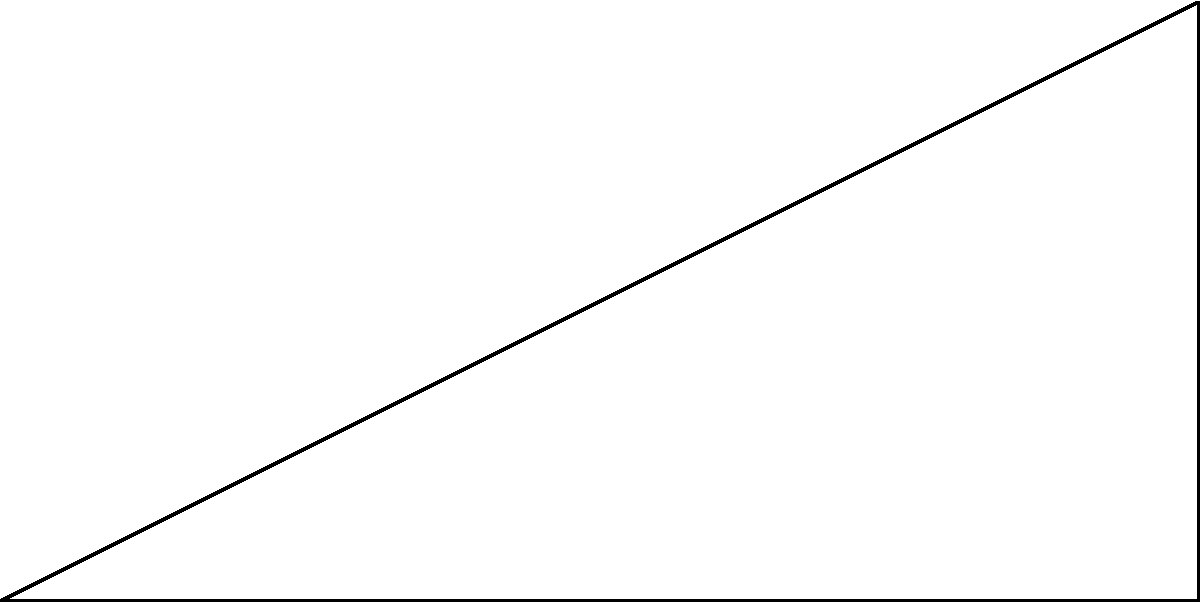As part of your documentary on Soviet-era architecture, you're examining a typical Khrushchyovka apartment building. Standing 60 meters away from the base of the building, you measure the angle of elevation to the top of the building to be 35°. Calculate the height of this Soviet-era apartment building to the nearest meter. Let's approach this step-by-step using trigonometry:

1) We can model this scenario as a right-angled triangle, where:
   - The adjacent side is the distance from you to the building (60 m)
   - The opposite side is the height of the building (what we're solving for)
   - The angle of elevation is 35°

2) In a right-angled triangle, we can use the tangent function to find the ratio of the opposite side to the adjacent side:

   $\tan(\theta) = \frac{\text{opposite}}{\text{adjacent}}$

3) In this case:

   $\tan(35°) = \frac{\text{height}}{60}$

4) To solve for the height, we multiply both sides by 60:

   $60 \cdot \tan(35°) = \text{height}$

5) Now we can calculate:
   
   $\text{height} = 60 \cdot \tan(35°)$
   $           \approx 60 \cdot 0.7002$
   $           \approx 42.01$ meters

6) Rounding to the nearest meter:

   $\text{height} \approx 42$ meters

Therefore, the height of the Soviet-era apartment building is approximately 42 meters.
Answer: 42 meters 